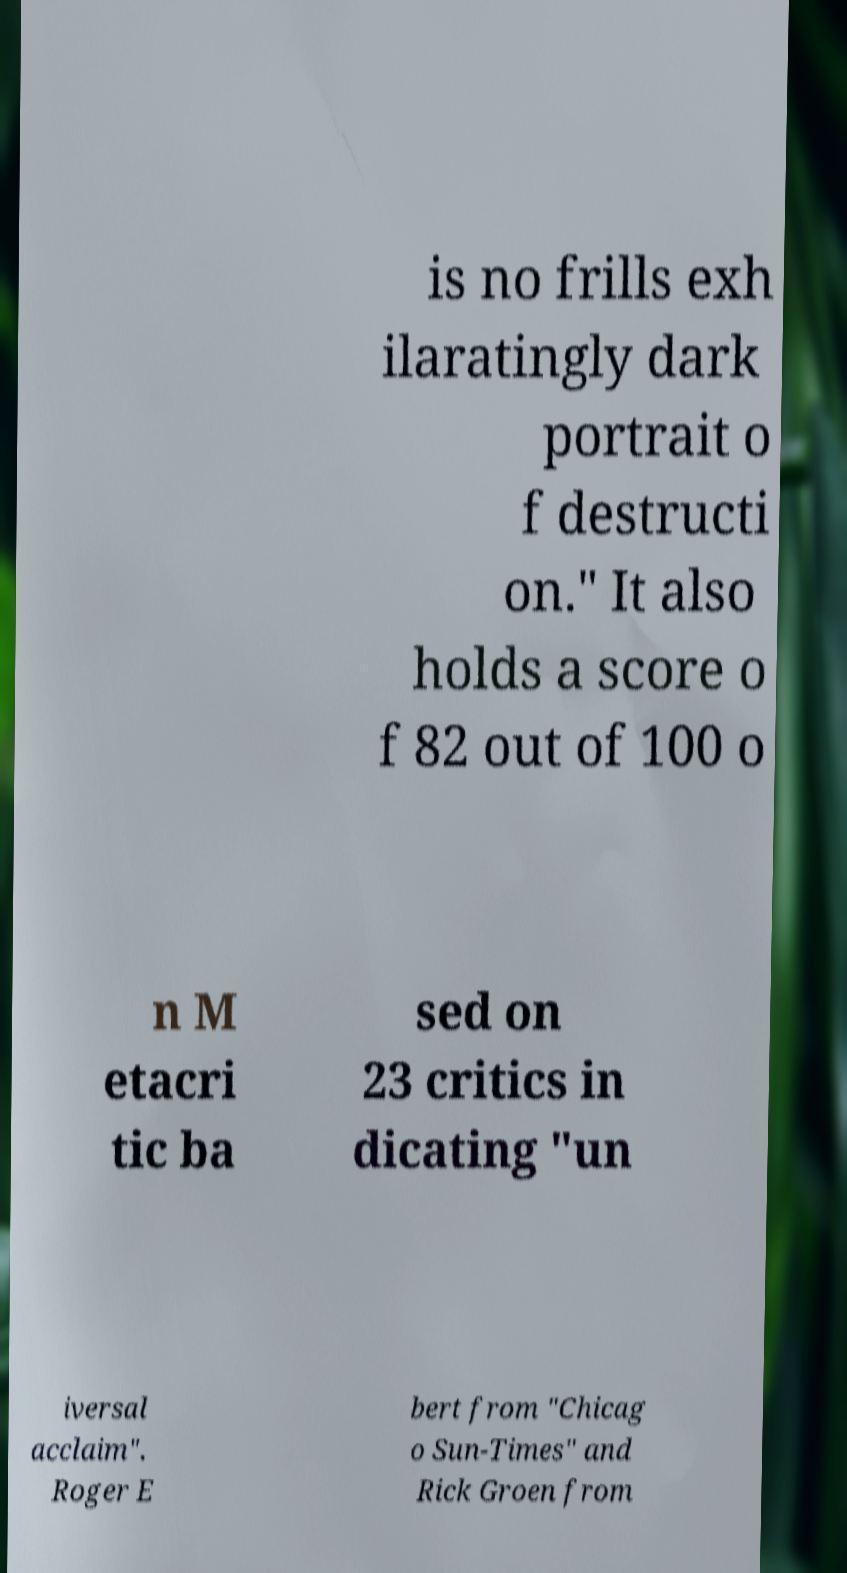Can you accurately transcribe the text from the provided image for me? is no frills exh ilaratingly dark portrait o f destructi on." It also holds a score o f 82 out of 100 o n M etacri tic ba sed on 23 critics in dicating "un iversal acclaim". Roger E bert from "Chicag o Sun-Times" and Rick Groen from 